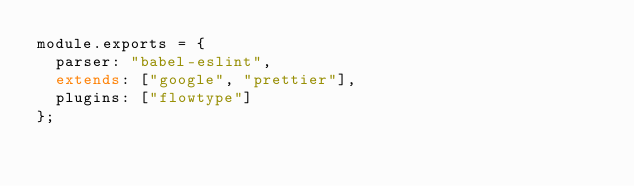<code> <loc_0><loc_0><loc_500><loc_500><_JavaScript_>module.exports = {
  parser: "babel-eslint",
  extends: ["google", "prettier"],
  plugins: ["flowtype"]
};
</code> 